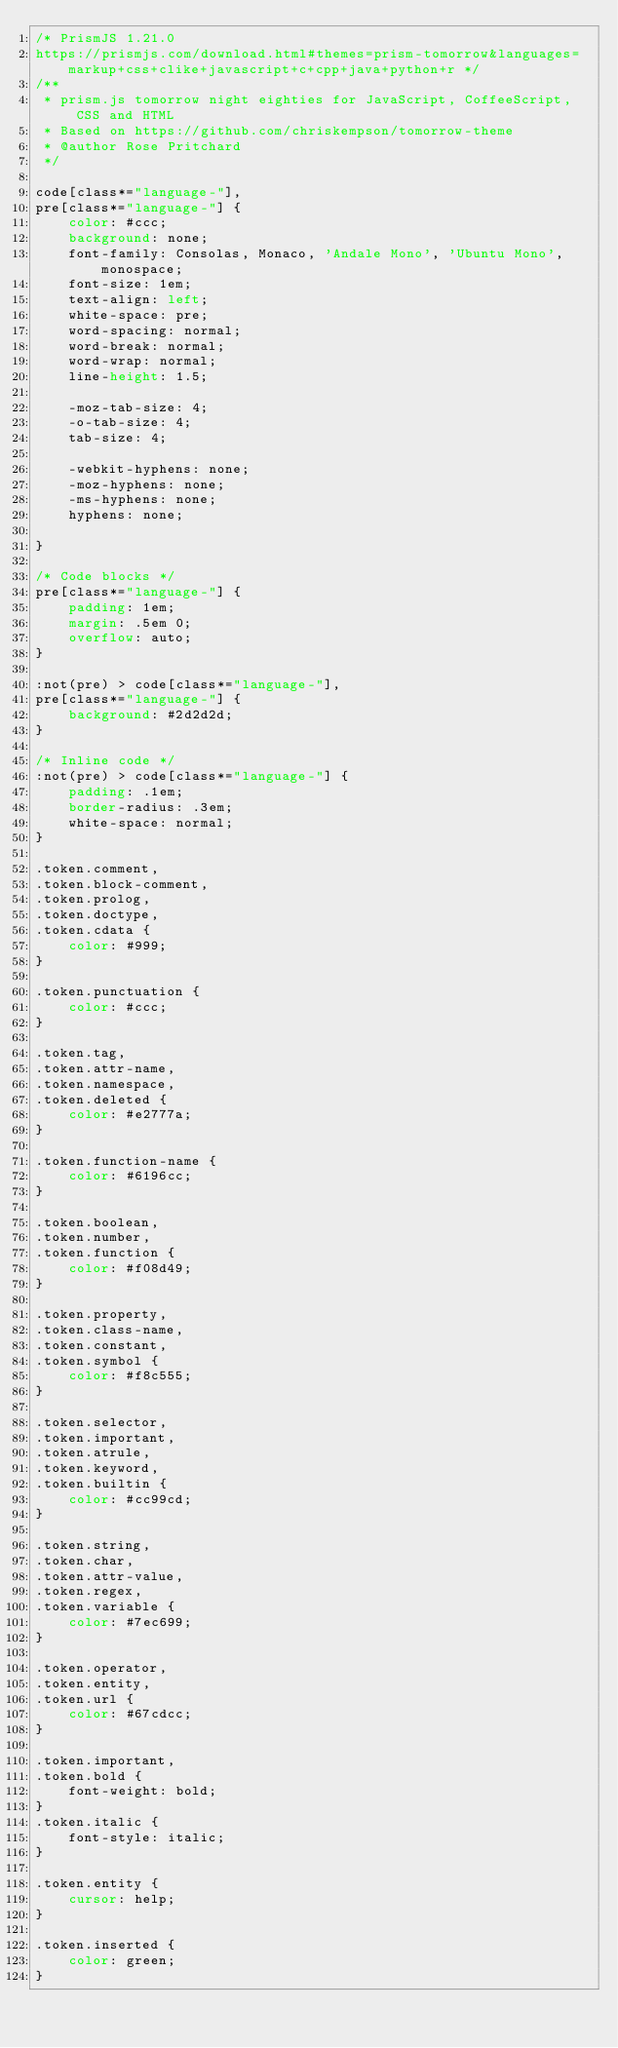<code> <loc_0><loc_0><loc_500><loc_500><_CSS_>/* PrismJS 1.21.0
https://prismjs.com/download.html#themes=prism-tomorrow&languages=markup+css+clike+javascript+c+cpp+java+python+r */
/**
 * prism.js tomorrow night eighties for JavaScript, CoffeeScript, CSS and HTML
 * Based on https://github.com/chriskempson/tomorrow-theme
 * @author Rose Pritchard
 */

code[class*="language-"],
pre[class*="language-"] {
	color: #ccc;
	background: none;
	font-family: Consolas, Monaco, 'Andale Mono', 'Ubuntu Mono', monospace;
	font-size: 1em;
	text-align: left;
	white-space: pre;
	word-spacing: normal;
	word-break: normal;
	word-wrap: normal;
	line-height: 1.5;

	-moz-tab-size: 4;
	-o-tab-size: 4;
	tab-size: 4;

	-webkit-hyphens: none;
	-moz-hyphens: none;
	-ms-hyphens: none;
	hyphens: none;

}

/* Code blocks */
pre[class*="language-"] {
	padding: 1em;
	margin: .5em 0;
	overflow: auto;
}

:not(pre) > code[class*="language-"],
pre[class*="language-"] {
	background: #2d2d2d;
}

/* Inline code */
:not(pre) > code[class*="language-"] {
	padding: .1em;
	border-radius: .3em;
	white-space: normal;
}

.token.comment,
.token.block-comment,
.token.prolog,
.token.doctype,
.token.cdata {
	color: #999;
}

.token.punctuation {
	color: #ccc;
}

.token.tag,
.token.attr-name,
.token.namespace,
.token.deleted {
	color: #e2777a;
}

.token.function-name {
	color: #6196cc;
}

.token.boolean,
.token.number,
.token.function {
	color: #f08d49;
}

.token.property,
.token.class-name,
.token.constant,
.token.symbol {
	color: #f8c555;
}

.token.selector,
.token.important,
.token.atrule,
.token.keyword,
.token.builtin {
	color: #cc99cd;
}

.token.string,
.token.char,
.token.attr-value,
.token.regex,
.token.variable {
	color: #7ec699;
}

.token.operator,
.token.entity,
.token.url {
	color: #67cdcc;
}

.token.important,
.token.bold {
	font-weight: bold;
}
.token.italic {
	font-style: italic;
}

.token.entity {
	cursor: help;
}

.token.inserted {
	color: green;
}

</code> 